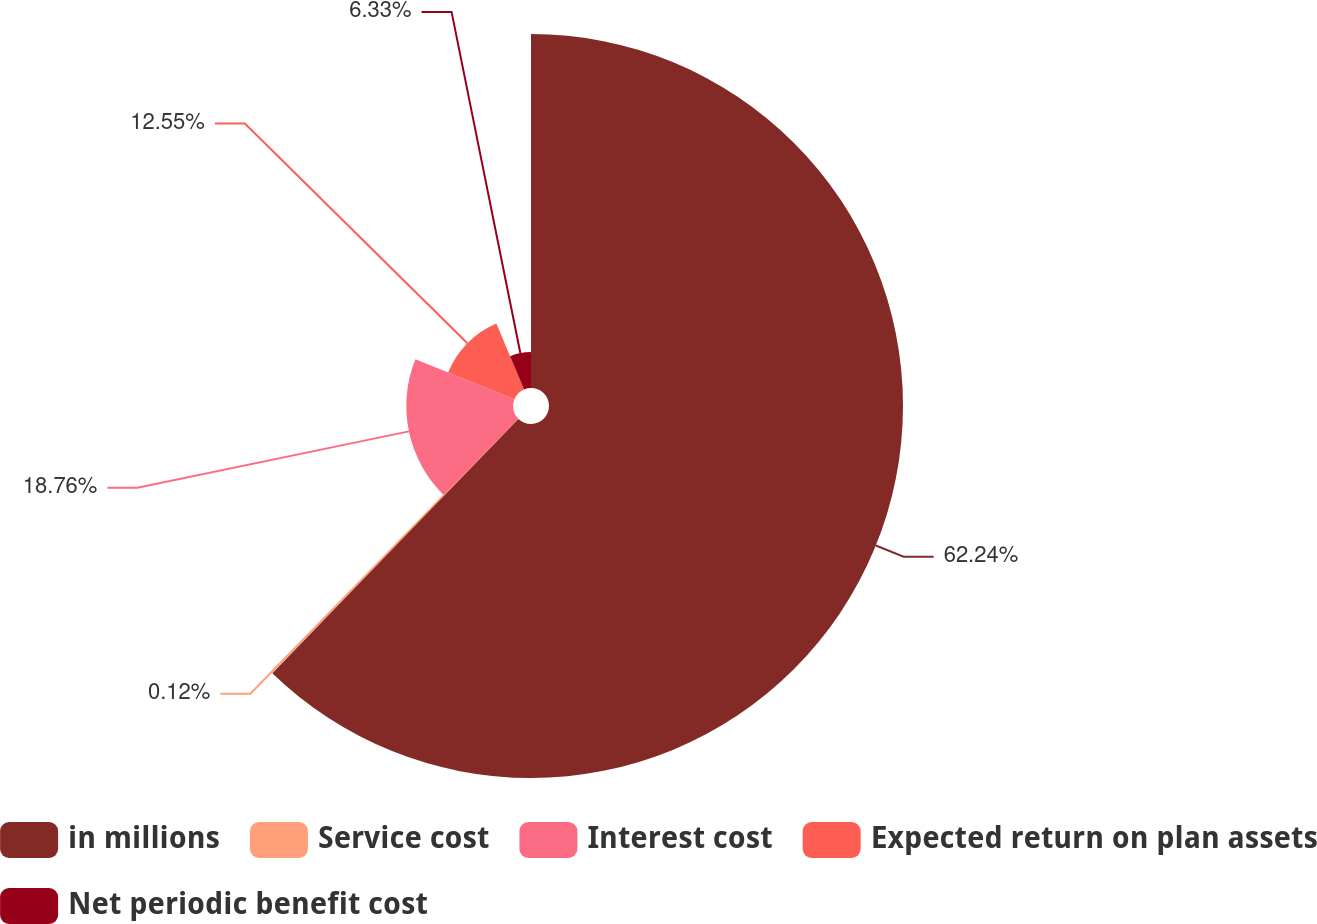<chart> <loc_0><loc_0><loc_500><loc_500><pie_chart><fcel>in millions<fcel>Service cost<fcel>Interest cost<fcel>Expected return on plan assets<fcel>Net periodic benefit cost<nl><fcel>62.24%<fcel>0.12%<fcel>18.76%<fcel>12.55%<fcel>6.33%<nl></chart> 